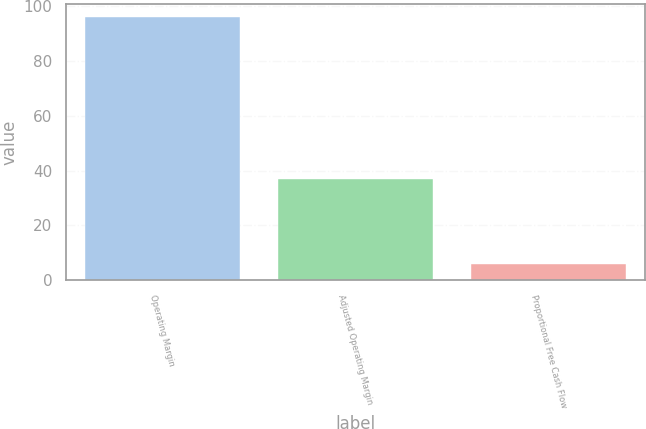<chart> <loc_0><loc_0><loc_500><loc_500><bar_chart><fcel>Operating Margin<fcel>Adjusted Operating Margin<fcel>Proportional Free Cash Flow<nl><fcel>96<fcel>37<fcel>6<nl></chart> 